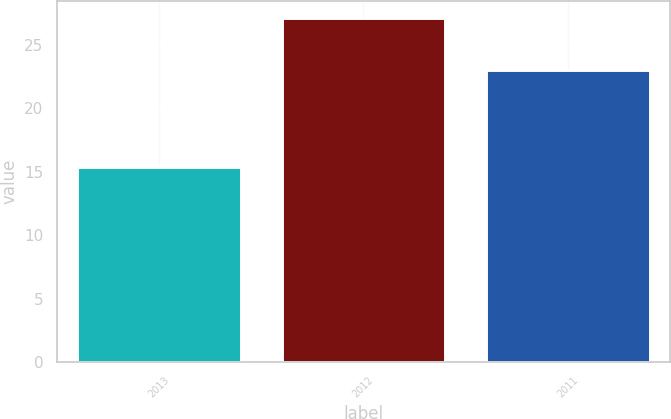Convert chart. <chart><loc_0><loc_0><loc_500><loc_500><bar_chart><fcel>2013<fcel>2012<fcel>2011<nl><fcel>15.4<fcel>27.1<fcel>23<nl></chart> 